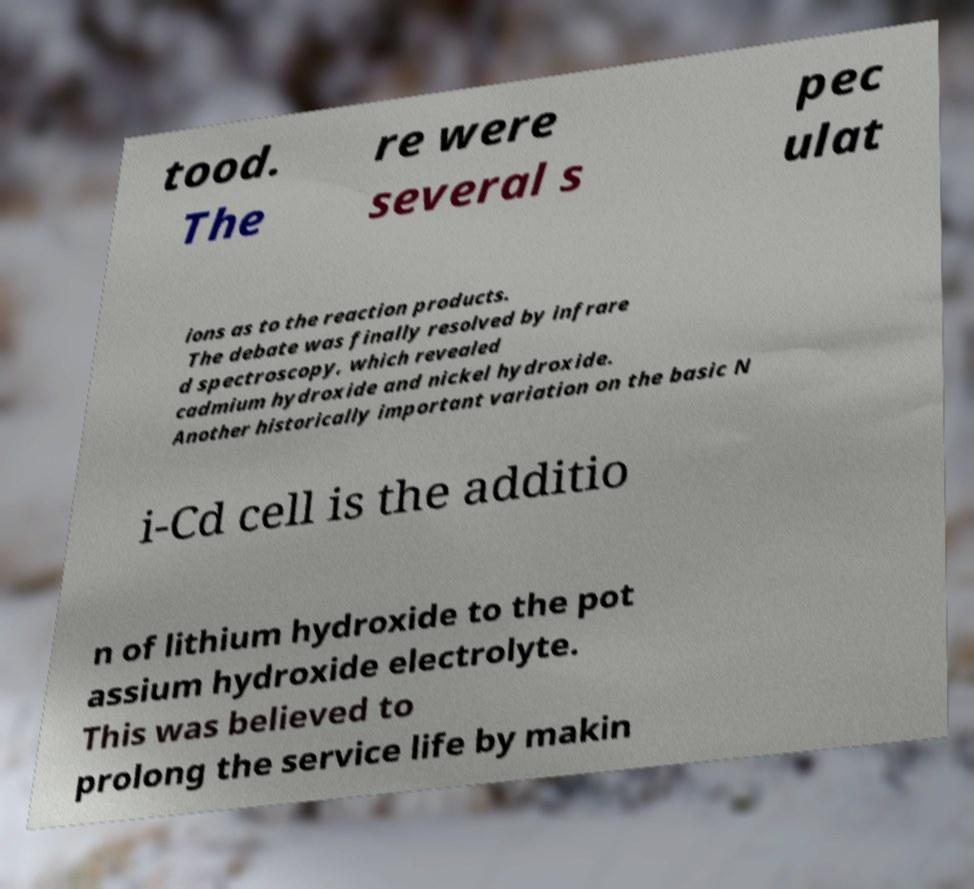Could you extract and type out the text from this image? tood. The re were several s pec ulat ions as to the reaction products. The debate was finally resolved by infrare d spectroscopy, which revealed cadmium hydroxide and nickel hydroxide. Another historically important variation on the basic N i-Cd cell is the additio n of lithium hydroxide to the pot assium hydroxide electrolyte. This was believed to prolong the service life by makin 